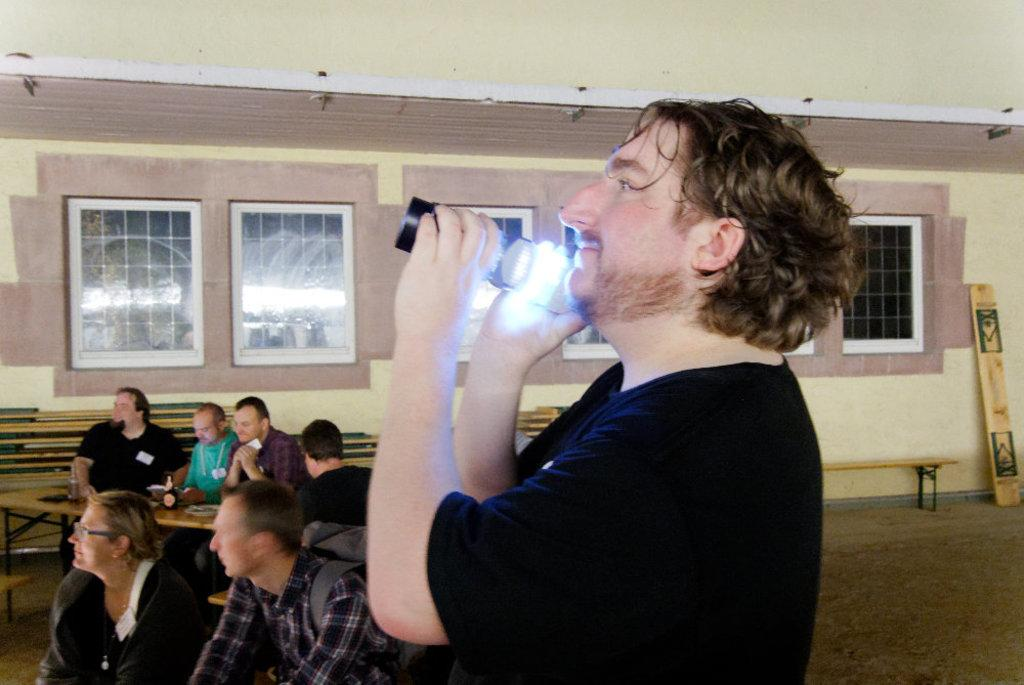What is the person in the image doing? The person is standing in the image and holding a torch light. Are there any other people in the image? Yes, there are people sitting on benches in the image. What can be seen in the background of the image? There is a wall with windows in the background of the image. What type of insect can be seen crawling on the person's hand in the image? There is no insect visible on the person's hand in the image. What kind of bun is being served to the people sitting on the benches? There is no bun present in the image. 